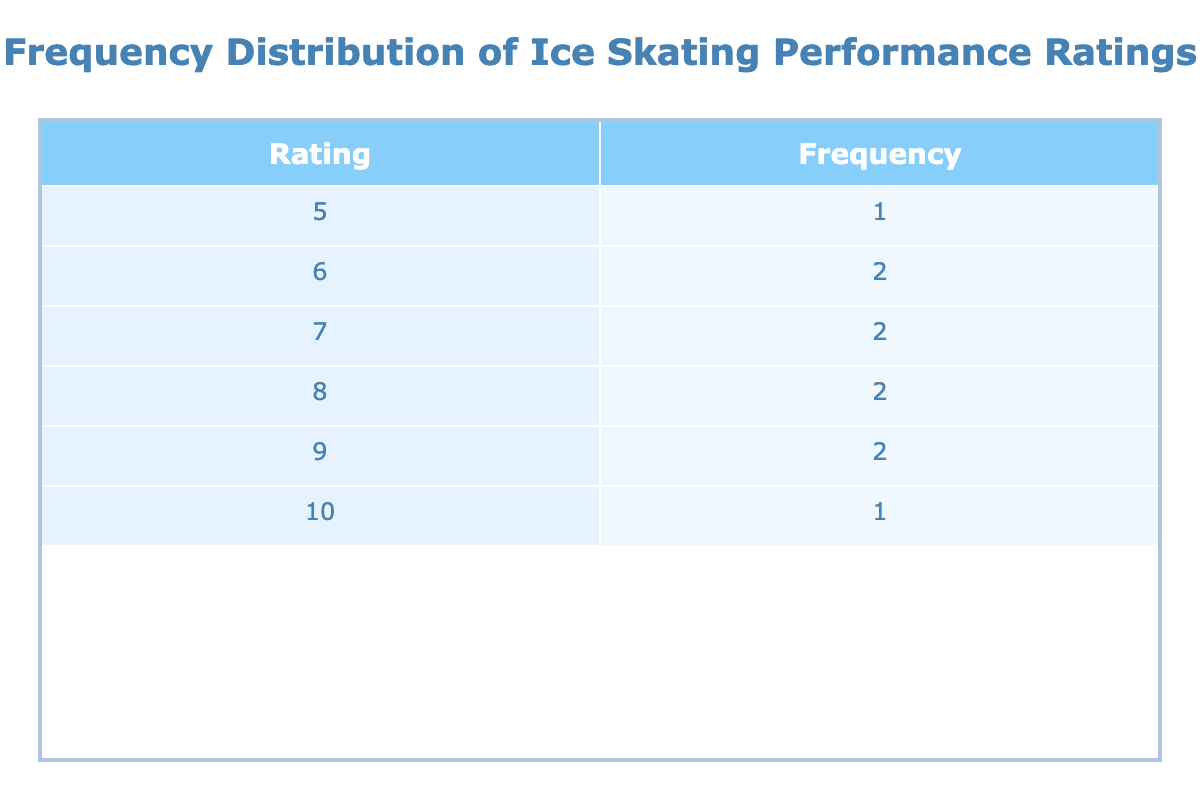What is the highest performance rating listed in the table? The table shows the performance ratings, and by inspecting the 'Rating' column, we can see that the maximum number is 10.
Answer: 10 How many actresses received a performance rating of 8? By looking at the 'Frequency' column associated with the rating of 8, we see a count of 2, indicating that two actresses received this rating.
Answer: 2 What is the average performance rating for all the actresses? To calculate the average, we sum the ratings (8 + 9 + 10 + 6 + 7 + 8 + 9 + 7 + 6 + 5 = 75) and divide by the number of actresses (10). Thus, the average rating is 75/10 = 7.5.
Answer: 7.5 Did Margot Robbie receive a performance rating of 9? By checking the table, it is clear that Margot Robbie is associated with the rating of 9 in her movie.
Answer: Yes What is the frequency difference between the ratings of 6 and 7? The table indicates that the frequency of rating 6 is 2 (from Jennifer Aniston and Chloë Grace Moretz) and the frequency of rating 7 is also 2 (from Anne Hathaway and Hailee Steinfeld). Therefore, the difference is 2 - 2 = 0.
Answer: 0 How many actresses have a performance rating lower than 7? By examining the ratings, we notice the ratings lower than 7 are 5 and 6. The actresses with these ratings are Mila Kunis (5) and two actresses with a rating of 6. So, 3 actresses in total have ratings lower than 7.
Answer: 3 Which performance rating has the highest frequency? Observing the table, performance ratings of 6 and 7 each have a frequency of 2, while all others have a frequency of 1 or 2. However, ratings of 6 and 7 both tie as the most frequent values, since there is no performance rating with higher frequency.
Answer: 6 and 7 What ratings did not receive any performances? Checking the performance ratings, we can see that the ratings 1, 2, 3, 4 are not listed in the table, meaning there were no performances for these ratings.
Answer: 1, 2, 3, 4 